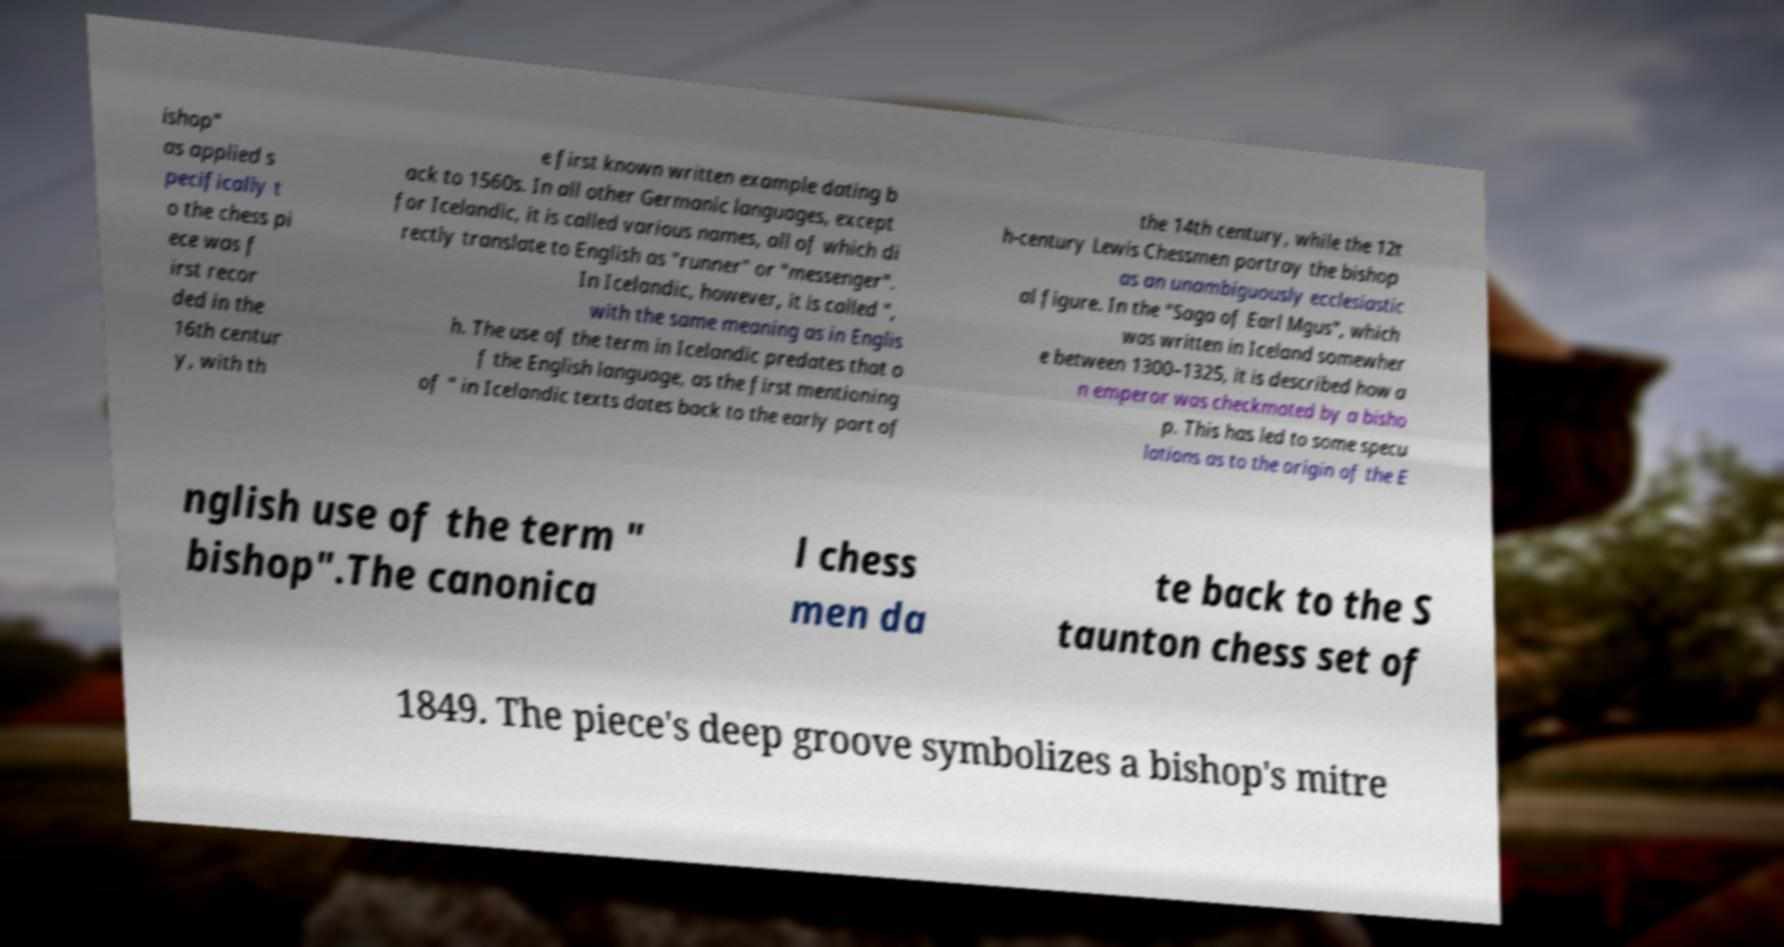What messages or text are displayed in this image? I need them in a readable, typed format. ishop" as applied s pecifically t o the chess pi ece was f irst recor ded in the 16th centur y, with th e first known written example dating b ack to 1560s. In all other Germanic languages, except for Icelandic, it is called various names, all of which di rectly translate to English as "runner" or "messenger". In Icelandic, however, it is called ", with the same meaning as in Englis h. The use of the term in Icelandic predates that o f the English language, as the first mentioning of " in Icelandic texts dates back to the early part of the 14th century, while the 12t h-century Lewis Chessmen portray the bishop as an unambiguously ecclesiastic al figure. In the "Saga of Earl Mgus", which was written in Iceland somewher e between 1300–1325, it is described how a n emperor was checkmated by a bisho p. This has led to some specu lations as to the origin of the E nglish use of the term " bishop".The canonica l chess men da te back to the S taunton chess set of 1849. The piece's deep groove symbolizes a bishop's mitre 